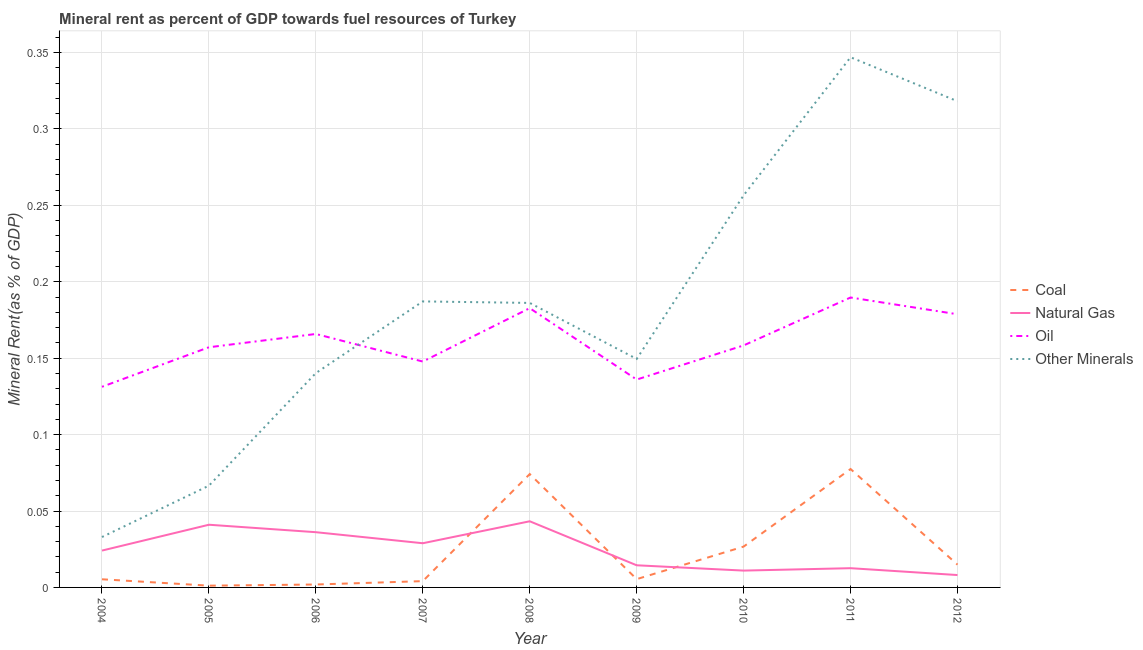How many different coloured lines are there?
Offer a very short reply. 4. Does the line corresponding to coal rent intersect with the line corresponding to oil rent?
Your answer should be very brief. No. Is the number of lines equal to the number of legend labels?
Ensure brevity in your answer.  Yes. What is the  rent of other minerals in 2009?
Provide a succinct answer. 0.15. Across all years, what is the maximum coal rent?
Make the answer very short. 0.08. Across all years, what is the minimum natural gas rent?
Ensure brevity in your answer.  0.01. In which year was the  rent of other minerals minimum?
Your answer should be compact. 2004. What is the total  rent of other minerals in the graph?
Provide a short and direct response. 1.68. What is the difference between the natural gas rent in 2005 and that in 2008?
Provide a short and direct response. -0. What is the difference between the oil rent in 2011 and the coal rent in 2004?
Your answer should be very brief. 0.18. What is the average oil rent per year?
Offer a terse response. 0.16. In the year 2011, what is the difference between the  rent of other minerals and natural gas rent?
Offer a very short reply. 0.33. In how many years, is the natural gas rent greater than 0.12000000000000001 %?
Offer a very short reply. 0. What is the ratio of the  rent of other minerals in 2008 to that in 2010?
Provide a succinct answer. 0.73. Is the oil rent in 2005 less than that in 2009?
Your response must be concise. No. Is the difference between the natural gas rent in 2007 and 2010 greater than the difference between the  rent of other minerals in 2007 and 2010?
Your answer should be very brief. Yes. What is the difference between the highest and the second highest  rent of other minerals?
Provide a short and direct response. 0.03. What is the difference between the highest and the lowest coal rent?
Your answer should be very brief. 0.08. Is the sum of the natural gas rent in 2005 and 2008 greater than the maximum  rent of other minerals across all years?
Provide a short and direct response. No. Is it the case that in every year, the sum of the  rent of other minerals and natural gas rent is greater than the sum of oil rent and coal rent?
Give a very brief answer. No. How many years are there in the graph?
Provide a succinct answer. 9. Does the graph contain any zero values?
Offer a very short reply. No. Does the graph contain grids?
Give a very brief answer. Yes. How are the legend labels stacked?
Ensure brevity in your answer.  Vertical. What is the title of the graph?
Your response must be concise. Mineral rent as percent of GDP towards fuel resources of Turkey. What is the label or title of the X-axis?
Your answer should be very brief. Year. What is the label or title of the Y-axis?
Make the answer very short. Mineral Rent(as % of GDP). What is the Mineral Rent(as % of GDP) in Coal in 2004?
Offer a terse response. 0.01. What is the Mineral Rent(as % of GDP) in Natural Gas in 2004?
Make the answer very short. 0.02. What is the Mineral Rent(as % of GDP) in Oil in 2004?
Offer a very short reply. 0.13. What is the Mineral Rent(as % of GDP) in Other Minerals in 2004?
Give a very brief answer. 0.03. What is the Mineral Rent(as % of GDP) of Coal in 2005?
Give a very brief answer. 0. What is the Mineral Rent(as % of GDP) in Natural Gas in 2005?
Your answer should be very brief. 0.04. What is the Mineral Rent(as % of GDP) in Oil in 2005?
Ensure brevity in your answer.  0.16. What is the Mineral Rent(as % of GDP) in Other Minerals in 2005?
Offer a very short reply. 0.07. What is the Mineral Rent(as % of GDP) in Coal in 2006?
Your answer should be compact. 0. What is the Mineral Rent(as % of GDP) of Natural Gas in 2006?
Make the answer very short. 0.04. What is the Mineral Rent(as % of GDP) in Oil in 2006?
Offer a very short reply. 0.17. What is the Mineral Rent(as % of GDP) in Other Minerals in 2006?
Keep it short and to the point. 0.14. What is the Mineral Rent(as % of GDP) of Coal in 2007?
Your response must be concise. 0. What is the Mineral Rent(as % of GDP) of Natural Gas in 2007?
Provide a succinct answer. 0.03. What is the Mineral Rent(as % of GDP) of Oil in 2007?
Offer a terse response. 0.15. What is the Mineral Rent(as % of GDP) of Other Minerals in 2007?
Ensure brevity in your answer.  0.19. What is the Mineral Rent(as % of GDP) in Coal in 2008?
Provide a succinct answer. 0.07. What is the Mineral Rent(as % of GDP) of Natural Gas in 2008?
Ensure brevity in your answer.  0.04. What is the Mineral Rent(as % of GDP) in Oil in 2008?
Your answer should be compact. 0.18. What is the Mineral Rent(as % of GDP) in Other Minerals in 2008?
Provide a succinct answer. 0.19. What is the Mineral Rent(as % of GDP) of Coal in 2009?
Keep it short and to the point. 0.01. What is the Mineral Rent(as % of GDP) in Natural Gas in 2009?
Keep it short and to the point. 0.01. What is the Mineral Rent(as % of GDP) of Oil in 2009?
Provide a succinct answer. 0.14. What is the Mineral Rent(as % of GDP) in Other Minerals in 2009?
Offer a very short reply. 0.15. What is the Mineral Rent(as % of GDP) in Coal in 2010?
Provide a succinct answer. 0.03. What is the Mineral Rent(as % of GDP) in Natural Gas in 2010?
Offer a very short reply. 0.01. What is the Mineral Rent(as % of GDP) of Oil in 2010?
Make the answer very short. 0.16. What is the Mineral Rent(as % of GDP) in Other Minerals in 2010?
Provide a succinct answer. 0.26. What is the Mineral Rent(as % of GDP) in Coal in 2011?
Offer a terse response. 0.08. What is the Mineral Rent(as % of GDP) of Natural Gas in 2011?
Provide a succinct answer. 0.01. What is the Mineral Rent(as % of GDP) in Oil in 2011?
Give a very brief answer. 0.19. What is the Mineral Rent(as % of GDP) of Other Minerals in 2011?
Your response must be concise. 0.35. What is the Mineral Rent(as % of GDP) in Coal in 2012?
Offer a terse response. 0.01. What is the Mineral Rent(as % of GDP) in Natural Gas in 2012?
Offer a terse response. 0.01. What is the Mineral Rent(as % of GDP) in Oil in 2012?
Give a very brief answer. 0.18. What is the Mineral Rent(as % of GDP) of Other Minerals in 2012?
Your answer should be very brief. 0.32. Across all years, what is the maximum Mineral Rent(as % of GDP) in Coal?
Keep it short and to the point. 0.08. Across all years, what is the maximum Mineral Rent(as % of GDP) in Natural Gas?
Make the answer very short. 0.04. Across all years, what is the maximum Mineral Rent(as % of GDP) in Oil?
Give a very brief answer. 0.19. Across all years, what is the maximum Mineral Rent(as % of GDP) in Other Minerals?
Offer a terse response. 0.35. Across all years, what is the minimum Mineral Rent(as % of GDP) in Coal?
Make the answer very short. 0. Across all years, what is the minimum Mineral Rent(as % of GDP) in Natural Gas?
Keep it short and to the point. 0.01. Across all years, what is the minimum Mineral Rent(as % of GDP) in Oil?
Provide a succinct answer. 0.13. Across all years, what is the minimum Mineral Rent(as % of GDP) in Other Minerals?
Give a very brief answer. 0.03. What is the total Mineral Rent(as % of GDP) in Coal in the graph?
Your answer should be very brief. 0.21. What is the total Mineral Rent(as % of GDP) in Natural Gas in the graph?
Keep it short and to the point. 0.22. What is the total Mineral Rent(as % of GDP) of Oil in the graph?
Your answer should be compact. 1.45. What is the total Mineral Rent(as % of GDP) in Other Minerals in the graph?
Provide a succinct answer. 1.68. What is the difference between the Mineral Rent(as % of GDP) in Coal in 2004 and that in 2005?
Offer a terse response. 0. What is the difference between the Mineral Rent(as % of GDP) in Natural Gas in 2004 and that in 2005?
Provide a short and direct response. -0.02. What is the difference between the Mineral Rent(as % of GDP) in Oil in 2004 and that in 2005?
Offer a terse response. -0.03. What is the difference between the Mineral Rent(as % of GDP) in Other Minerals in 2004 and that in 2005?
Offer a terse response. -0.03. What is the difference between the Mineral Rent(as % of GDP) of Coal in 2004 and that in 2006?
Give a very brief answer. 0. What is the difference between the Mineral Rent(as % of GDP) in Natural Gas in 2004 and that in 2006?
Provide a short and direct response. -0.01. What is the difference between the Mineral Rent(as % of GDP) in Oil in 2004 and that in 2006?
Your answer should be compact. -0.03. What is the difference between the Mineral Rent(as % of GDP) of Other Minerals in 2004 and that in 2006?
Make the answer very short. -0.11. What is the difference between the Mineral Rent(as % of GDP) of Coal in 2004 and that in 2007?
Give a very brief answer. 0. What is the difference between the Mineral Rent(as % of GDP) in Natural Gas in 2004 and that in 2007?
Your answer should be compact. -0. What is the difference between the Mineral Rent(as % of GDP) in Oil in 2004 and that in 2007?
Your response must be concise. -0.02. What is the difference between the Mineral Rent(as % of GDP) in Other Minerals in 2004 and that in 2007?
Keep it short and to the point. -0.15. What is the difference between the Mineral Rent(as % of GDP) of Coal in 2004 and that in 2008?
Offer a very short reply. -0.07. What is the difference between the Mineral Rent(as % of GDP) of Natural Gas in 2004 and that in 2008?
Provide a succinct answer. -0.02. What is the difference between the Mineral Rent(as % of GDP) in Oil in 2004 and that in 2008?
Your answer should be very brief. -0.05. What is the difference between the Mineral Rent(as % of GDP) in Other Minerals in 2004 and that in 2008?
Ensure brevity in your answer.  -0.15. What is the difference between the Mineral Rent(as % of GDP) of Coal in 2004 and that in 2009?
Provide a short and direct response. -0. What is the difference between the Mineral Rent(as % of GDP) in Natural Gas in 2004 and that in 2009?
Your answer should be compact. 0.01. What is the difference between the Mineral Rent(as % of GDP) in Oil in 2004 and that in 2009?
Offer a very short reply. -0. What is the difference between the Mineral Rent(as % of GDP) in Other Minerals in 2004 and that in 2009?
Your response must be concise. -0.12. What is the difference between the Mineral Rent(as % of GDP) of Coal in 2004 and that in 2010?
Your response must be concise. -0.02. What is the difference between the Mineral Rent(as % of GDP) in Natural Gas in 2004 and that in 2010?
Offer a very short reply. 0.01. What is the difference between the Mineral Rent(as % of GDP) in Oil in 2004 and that in 2010?
Your answer should be compact. -0.03. What is the difference between the Mineral Rent(as % of GDP) of Other Minerals in 2004 and that in 2010?
Keep it short and to the point. -0.22. What is the difference between the Mineral Rent(as % of GDP) of Coal in 2004 and that in 2011?
Keep it short and to the point. -0.07. What is the difference between the Mineral Rent(as % of GDP) of Natural Gas in 2004 and that in 2011?
Offer a very short reply. 0.01. What is the difference between the Mineral Rent(as % of GDP) of Oil in 2004 and that in 2011?
Provide a succinct answer. -0.06. What is the difference between the Mineral Rent(as % of GDP) in Other Minerals in 2004 and that in 2011?
Your answer should be very brief. -0.31. What is the difference between the Mineral Rent(as % of GDP) in Coal in 2004 and that in 2012?
Offer a terse response. -0.01. What is the difference between the Mineral Rent(as % of GDP) in Natural Gas in 2004 and that in 2012?
Your answer should be very brief. 0.02. What is the difference between the Mineral Rent(as % of GDP) in Oil in 2004 and that in 2012?
Give a very brief answer. -0.05. What is the difference between the Mineral Rent(as % of GDP) of Other Minerals in 2004 and that in 2012?
Your response must be concise. -0.29. What is the difference between the Mineral Rent(as % of GDP) of Coal in 2005 and that in 2006?
Your response must be concise. -0. What is the difference between the Mineral Rent(as % of GDP) of Natural Gas in 2005 and that in 2006?
Your answer should be compact. 0. What is the difference between the Mineral Rent(as % of GDP) of Oil in 2005 and that in 2006?
Offer a terse response. -0.01. What is the difference between the Mineral Rent(as % of GDP) in Other Minerals in 2005 and that in 2006?
Your answer should be very brief. -0.07. What is the difference between the Mineral Rent(as % of GDP) of Coal in 2005 and that in 2007?
Provide a short and direct response. -0. What is the difference between the Mineral Rent(as % of GDP) in Natural Gas in 2005 and that in 2007?
Provide a succinct answer. 0.01. What is the difference between the Mineral Rent(as % of GDP) of Oil in 2005 and that in 2007?
Keep it short and to the point. 0.01. What is the difference between the Mineral Rent(as % of GDP) in Other Minerals in 2005 and that in 2007?
Your answer should be very brief. -0.12. What is the difference between the Mineral Rent(as % of GDP) in Coal in 2005 and that in 2008?
Offer a very short reply. -0.07. What is the difference between the Mineral Rent(as % of GDP) in Natural Gas in 2005 and that in 2008?
Keep it short and to the point. -0. What is the difference between the Mineral Rent(as % of GDP) in Oil in 2005 and that in 2008?
Your answer should be very brief. -0.03. What is the difference between the Mineral Rent(as % of GDP) in Other Minerals in 2005 and that in 2008?
Your answer should be compact. -0.12. What is the difference between the Mineral Rent(as % of GDP) in Coal in 2005 and that in 2009?
Provide a succinct answer. -0. What is the difference between the Mineral Rent(as % of GDP) in Natural Gas in 2005 and that in 2009?
Provide a short and direct response. 0.03. What is the difference between the Mineral Rent(as % of GDP) in Oil in 2005 and that in 2009?
Your answer should be very brief. 0.02. What is the difference between the Mineral Rent(as % of GDP) in Other Minerals in 2005 and that in 2009?
Give a very brief answer. -0.08. What is the difference between the Mineral Rent(as % of GDP) in Coal in 2005 and that in 2010?
Keep it short and to the point. -0.03. What is the difference between the Mineral Rent(as % of GDP) of Oil in 2005 and that in 2010?
Keep it short and to the point. -0. What is the difference between the Mineral Rent(as % of GDP) of Other Minerals in 2005 and that in 2010?
Offer a very short reply. -0.19. What is the difference between the Mineral Rent(as % of GDP) of Coal in 2005 and that in 2011?
Provide a short and direct response. -0.08. What is the difference between the Mineral Rent(as % of GDP) in Natural Gas in 2005 and that in 2011?
Your answer should be very brief. 0.03. What is the difference between the Mineral Rent(as % of GDP) in Oil in 2005 and that in 2011?
Your answer should be compact. -0.03. What is the difference between the Mineral Rent(as % of GDP) in Other Minerals in 2005 and that in 2011?
Ensure brevity in your answer.  -0.28. What is the difference between the Mineral Rent(as % of GDP) of Coal in 2005 and that in 2012?
Your answer should be very brief. -0.01. What is the difference between the Mineral Rent(as % of GDP) in Natural Gas in 2005 and that in 2012?
Make the answer very short. 0.03. What is the difference between the Mineral Rent(as % of GDP) in Oil in 2005 and that in 2012?
Make the answer very short. -0.02. What is the difference between the Mineral Rent(as % of GDP) in Other Minerals in 2005 and that in 2012?
Your response must be concise. -0.25. What is the difference between the Mineral Rent(as % of GDP) of Coal in 2006 and that in 2007?
Provide a succinct answer. -0. What is the difference between the Mineral Rent(as % of GDP) of Natural Gas in 2006 and that in 2007?
Provide a succinct answer. 0.01. What is the difference between the Mineral Rent(as % of GDP) of Oil in 2006 and that in 2007?
Make the answer very short. 0.02. What is the difference between the Mineral Rent(as % of GDP) of Other Minerals in 2006 and that in 2007?
Your answer should be compact. -0.05. What is the difference between the Mineral Rent(as % of GDP) in Coal in 2006 and that in 2008?
Provide a short and direct response. -0.07. What is the difference between the Mineral Rent(as % of GDP) in Natural Gas in 2006 and that in 2008?
Your answer should be compact. -0.01. What is the difference between the Mineral Rent(as % of GDP) in Oil in 2006 and that in 2008?
Give a very brief answer. -0.02. What is the difference between the Mineral Rent(as % of GDP) of Other Minerals in 2006 and that in 2008?
Ensure brevity in your answer.  -0.05. What is the difference between the Mineral Rent(as % of GDP) of Coal in 2006 and that in 2009?
Your answer should be compact. -0. What is the difference between the Mineral Rent(as % of GDP) of Natural Gas in 2006 and that in 2009?
Offer a terse response. 0.02. What is the difference between the Mineral Rent(as % of GDP) in Oil in 2006 and that in 2009?
Offer a terse response. 0.03. What is the difference between the Mineral Rent(as % of GDP) in Other Minerals in 2006 and that in 2009?
Give a very brief answer. -0.01. What is the difference between the Mineral Rent(as % of GDP) of Coal in 2006 and that in 2010?
Make the answer very short. -0.02. What is the difference between the Mineral Rent(as % of GDP) in Natural Gas in 2006 and that in 2010?
Make the answer very short. 0.03. What is the difference between the Mineral Rent(as % of GDP) of Oil in 2006 and that in 2010?
Your answer should be very brief. 0.01. What is the difference between the Mineral Rent(as % of GDP) in Other Minerals in 2006 and that in 2010?
Your answer should be very brief. -0.12. What is the difference between the Mineral Rent(as % of GDP) in Coal in 2006 and that in 2011?
Keep it short and to the point. -0.08. What is the difference between the Mineral Rent(as % of GDP) of Natural Gas in 2006 and that in 2011?
Your answer should be compact. 0.02. What is the difference between the Mineral Rent(as % of GDP) in Oil in 2006 and that in 2011?
Keep it short and to the point. -0.02. What is the difference between the Mineral Rent(as % of GDP) of Other Minerals in 2006 and that in 2011?
Your answer should be compact. -0.21. What is the difference between the Mineral Rent(as % of GDP) in Coal in 2006 and that in 2012?
Offer a terse response. -0.01. What is the difference between the Mineral Rent(as % of GDP) of Natural Gas in 2006 and that in 2012?
Provide a succinct answer. 0.03. What is the difference between the Mineral Rent(as % of GDP) in Oil in 2006 and that in 2012?
Your answer should be very brief. -0.01. What is the difference between the Mineral Rent(as % of GDP) in Other Minerals in 2006 and that in 2012?
Provide a succinct answer. -0.18. What is the difference between the Mineral Rent(as % of GDP) in Coal in 2007 and that in 2008?
Your answer should be very brief. -0.07. What is the difference between the Mineral Rent(as % of GDP) of Natural Gas in 2007 and that in 2008?
Provide a succinct answer. -0.01. What is the difference between the Mineral Rent(as % of GDP) of Oil in 2007 and that in 2008?
Your response must be concise. -0.03. What is the difference between the Mineral Rent(as % of GDP) of Other Minerals in 2007 and that in 2008?
Your answer should be compact. 0. What is the difference between the Mineral Rent(as % of GDP) of Coal in 2007 and that in 2009?
Provide a short and direct response. -0. What is the difference between the Mineral Rent(as % of GDP) in Natural Gas in 2007 and that in 2009?
Offer a very short reply. 0.01. What is the difference between the Mineral Rent(as % of GDP) of Oil in 2007 and that in 2009?
Ensure brevity in your answer.  0.01. What is the difference between the Mineral Rent(as % of GDP) of Other Minerals in 2007 and that in 2009?
Your answer should be very brief. 0.04. What is the difference between the Mineral Rent(as % of GDP) in Coal in 2007 and that in 2010?
Make the answer very short. -0.02. What is the difference between the Mineral Rent(as % of GDP) of Natural Gas in 2007 and that in 2010?
Ensure brevity in your answer.  0.02. What is the difference between the Mineral Rent(as % of GDP) of Oil in 2007 and that in 2010?
Your answer should be compact. -0.01. What is the difference between the Mineral Rent(as % of GDP) of Other Minerals in 2007 and that in 2010?
Keep it short and to the point. -0.07. What is the difference between the Mineral Rent(as % of GDP) in Coal in 2007 and that in 2011?
Ensure brevity in your answer.  -0.07. What is the difference between the Mineral Rent(as % of GDP) in Natural Gas in 2007 and that in 2011?
Keep it short and to the point. 0.02. What is the difference between the Mineral Rent(as % of GDP) of Oil in 2007 and that in 2011?
Your response must be concise. -0.04. What is the difference between the Mineral Rent(as % of GDP) of Other Minerals in 2007 and that in 2011?
Provide a succinct answer. -0.16. What is the difference between the Mineral Rent(as % of GDP) in Coal in 2007 and that in 2012?
Provide a short and direct response. -0.01. What is the difference between the Mineral Rent(as % of GDP) of Natural Gas in 2007 and that in 2012?
Your answer should be compact. 0.02. What is the difference between the Mineral Rent(as % of GDP) of Oil in 2007 and that in 2012?
Provide a succinct answer. -0.03. What is the difference between the Mineral Rent(as % of GDP) in Other Minerals in 2007 and that in 2012?
Offer a very short reply. -0.13. What is the difference between the Mineral Rent(as % of GDP) in Coal in 2008 and that in 2009?
Your answer should be very brief. 0.07. What is the difference between the Mineral Rent(as % of GDP) of Natural Gas in 2008 and that in 2009?
Give a very brief answer. 0.03. What is the difference between the Mineral Rent(as % of GDP) in Oil in 2008 and that in 2009?
Make the answer very short. 0.05. What is the difference between the Mineral Rent(as % of GDP) of Other Minerals in 2008 and that in 2009?
Provide a short and direct response. 0.04. What is the difference between the Mineral Rent(as % of GDP) in Coal in 2008 and that in 2010?
Provide a succinct answer. 0.05. What is the difference between the Mineral Rent(as % of GDP) of Natural Gas in 2008 and that in 2010?
Your answer should be compact. 0.03. What is the difference between the Mineral Rent(as % of GDP) of Oil in 2008 and that in 2010?
Your answer should be very brief. 0.02. What is the difference between the Mineral Rent(as % of GDP) of Other Minerals in 2008 and that in 2010?
Your response must be concise. -0.07. What is the difference between the Mineral Rent(as % of GDP) of Coal in 2008 and that in 2011?
Provide a succinct answer. -0. What is the difference between the Mineral Rent(as % of GDP) of Natural Gas in 2008 and that in 2011?
Make the answer very short. 0.03. What is the difference between the Mineral Rent(as % of GDP) of Oil in 2008 and that in 2011?
Provide a succinct answer. -0.01. What is the difference between the Mineral Rent(as % of GDP) of Other Minerals in 2008 and that in 2011?
Your response must be concise. -0.16. What is the difference between the Mineral Rent(as % of GDP) in Coal in 2008 and that in 2012?
Provide a succinct answer. 0.06. What is the difference between the Mineral Rent(as % of GDP) of Natural Gas in 2008 and that in 2012?
Make the answer very short. 0.04. What is the difference between the Mineral Rent(as % of GDP) of Oil in 2008 and that in 2012?
Keep it short and to the point. 0. What is the difference between the Mineral Rent(as % of GDP) of Other Minerals in 2008 and that in 2012?
Provide a short and direct response. -0.13. What is the difference between the Mineral Rent(as % of GDP) in Coal in 2009 and that in 2010?
Your answer should be very brief. -0.02. What is the difference between the Mineral Rent(as % of GDP) in Natural Gas in 2009 and that in 2010?
Keep it short and to the point. 0. What is the difference between the Mineral Rent(as % of GDP) in Oil in 2009 and that in 2010?
Your response must be concise. -0.02. What is the difference between the Mineral Rent(as % of GDP) in Other Minerals in 2009 and that in 2010?
Your answer should be very brief. -0.11. What is the difference between the Mineral Rent(as % of GDP) in Coal in 2009 and that in 2011?
Make the answer very short. -0.07. What is the difference between the Mineral Rent(as % of GDP) of Natural Gas in 2009 and that in 2011?
Keep it short and to the point. 0. What is the difference between the Mineral Rent(as % of GDP) in Oil in 2009 and that in 2011?
Provide a short and direct response. -0.05. What is the difference between the Mineral Rent(as % of GDP) of Other Minerals in 2009 and that in 2011?
Give a very brief answer. -0.2. What is the difference between the Mineral Rent(as % of GDP) of Coal in 2009 and that in 2012?
Offer a very short reply. -0.01. What is the difference between the Mineral Rent(as % of GDP) of Natural Gas in 2009 and that in 2012?
Provide a succinct answer. 0.01. What is the difference between the Mineral Rent(as % of GDP) of Oil in 2009 and that in 2012?
Offer a terse response. -0.04. What is the difference between the Mineral Rent(as % of GDP) of Other Minerals in 2009 and that in 2012?
Your answer should be compact. -0.17. What is the difference between the Mineral Rent(as % of GDP) of Coal in 2010 and that in 2011?
Your answer should be very brief. -0.05. What is the difference between the Mineral Rent(as % of GDP) in Natural Gas in 2010 and that in 2011?
Your answer should be very brief. -0. What is the difference between the Mineral Rent(as % of GDP) of Oil in 2010 and that in 2011?
Your answer should be compact. -0.03. What is the difference between the Mineral Rent(as % of GDP) in Other Minerals in 2010 and that in 2011?
Offer a terse response. -0.09. What is the difference between the Mineral Rent(as % of GDP) of Coal in 2010 and that in 2012?
Make the answer very short. 0.01. What is the difference between the Mineral Rent(as % of GDP) in Natural Gas in 2010 and that in 2012?
Provide a short and direct response. 0. What is the difference between the Mineral Rent(as % of GDP) in Oil in 2010 and that in 2012?
Your response must be concise. -0.02. What is the difference between the Mineral Rent(as % of GDP) in Other Minerals in 2010 and that in 2012?
Offer a terse response. -0.06. What is the difference between the Mineral Rent(as % of GDP) of Coal in 2011 and that in 2012?
Offer a very short reply. 0.06. What is the difference between the Mineral Rent(as % of GDP) of Natural Gas in 2011 and that in 2012?
Your response must be concise. 0. What is the difference between the Mineral Rent(as % of GDP) in Oil in 2011 and that in 2012?
Ensure brevity in your answer.  0.01. What is the difference between the Mineral Rent(as % of GDP) of Other Minerals in 2011 and that in 2012?
Give a very brief answer. 0.03. What is the difference between the Mineral Rent(as % of GDP) in Coal in 2004 and the Mineral Rent(as % of GDP) in Natural Gas in 2005?
Keep it short and to the point. -0.04. What is the difference between the Mineral Rent(as % of GDP) of Coal in 2004 and the Mineral Rent(as % of GDP) of Oil in 2005?
Give a very brief answer. -0.15. What is the difference between the Mineral Rent(as % of GDP) of Coal in 2004 and the Mineral Rent(as % of GDP) of Other Minerals in 2005?
Provide a succinct answer. -0.06. What is the difference between the Mineral Rent(as % of GDP) in Natural Gas in 2004 and the Mineral Rent(as % of GDP) in Oil in 2005?
Keep it short and to the point. -0.13. What is the difference between the Mineral Rent(as % of GDP) in Natural Gas in 2004 and the Mineral Rent(as % of GDP) in Other Minerals in 2005?
Your answer should be very brief. -0.04. What is the difference between the Mineral Rent(as % of GDP) in Oil in 2004 and the Mineral Rent(as % of GDP) in Other Minerals in 2005?
Your response must be concise. 0.06. What is the difference between the Mineral Rent(as % of GDP) of Coal in 2004 and the Mineral Rent(as % of GDP) of Natural Gas in 2006?
Provide a short and direct response. -0.03. What is the difference between the Mineral Rent(as % of GDP) in Coal in 2004 and the Mineral Rent(as % of GDP) in Oil in 2006?
Your answer should be compact. -0.16. What is the difference between the Mineral Rent(as % of GDP) in Coal in 2004 and the Mineral Rent(as % of GDP) in Other Minerals in 2006?
Offer a terse response. -0.13. What is the difference between the Mineral Rent(as % of GDP) in Natural Gas in 2004 and the Mineral Rent(as % of GDP) in Oil in 2006?
Give a very brief answer. -0.14. What is the difference between the Mineral Rent(as % of GDP) of Natural Gas in 2004 and the Mineral Rent(as % of GDP) of Other Minerals in 2006?
Offer a very short reply. -0.12. What is the difference between the Mineral Rent(as % of GDP) in Oil in 2004 and the Mineral Rent(as % of GDP) in Other Minerals in 2006?
Offer a very short reply. -0.01. What is the difference between the Mineral Rent(as % of GDP) of Coal in 2004 and the Mineral Rent(as % of GDP) of Natural Gas in 2007?
Your answer should be very brief. -0.02. What is the difference between the Mineral Rent(as % of GDP) in Coal in 2004 and the Mineral Rent(as % of GDP) in Oil in 2007?
Your response must be concise. -0.14. What is the difference between the Mineral Rent(as % of GDP) of Coal in 2004 and the Mineral Rent(as % of GDP) of Other Minerals in 2007?
Make the answer very short. -0.18. What is the difference between the Mineral Rent(as % of GDP) in Natural Gas in 2004 and the Mineral Rent(as % of GDP) in Oil in 2007?
Your response must be concise. -0.12. What is the difference between the Mineral Rent(as % of GDP) in Natural Gas in 2004 and the Mineral Rent(as % of GDP) in Other Minerals in 2007?
Provide a short and direct response. -0.16. What is the difference between the Mineral Rent(as % of GDP) of Oil in 2004 and the Mineral Rent(as % of GDP) of Other Minerals in 2007?
Your response must be concise. -0.06. What is the difference between the Mineral Rent(as % of GDP) in Coal in 2004 and the Mineral Rent(as % of GDP) in Natural Gas in 2008?
Provide a short and direct response. -0.04. What is the difference between the Mineral Rent(as % of GDP) in Coal in 2004 and the Mineral Rent(as % of GDP) in Oil in 2008?
Your answer should be compact. -0.18. What is the difference between the Mineral Rent(as % of GDP) in Coal in 2004 and the Mineral Rent(as % of GDP) in Other Minerals in 2008?
Your answer should be compact. -0.18. What is the difference between the Mineral Rent(as % of GDP) of Natural Gas in 2004 and the Mineral Rent(as % of GDP) of Oil in 2008?
Offer a very short reply. -0.16. What is the difference between the Mineral Rent(as % of GDP) of Natural Gas in 2004 and the Mineral Rent(as % of GDP) of Other Minerals in 2008?
Make the answer very short. -0.16. What is the difference between the Mineral Rent(as % of GDP) in Oil in 2004 and the Mineral Rent(as % of GDP) in Other Minerals in 2008?
Ensure brevity in your answer.  -0.05. What is the difference between the Mineral Rent(as % of GDP) of Coal in 2004 and the Mineral Rent(as % of GDP) of Natural Gas in 2009?
Provide a succinct answer. -0.01. What is the difference between the Mineral Rent(as % of GDP) of Coal in 2004 and the Mineral Rent(as % of GDP) of Oil in 2009?
Your answer should be very brief. -0.13. What is the difference between the Mineral Rent(as % of GDP) in Coal in 2004 and the Mineral Rent(as % of GDP) in Other Minerals in 2009?
Offer a very short reply. -0.14. What is the difference between the Mineral Rent(as % of GDP) in Natural Gas in 2004 and the Mineral Rent(as % of GDP) in Oil in 2009?
Provide a short and direct response. -0.11. What is the difference between the Mineral Rent(as % of GDP) of Natural Gas in 2004 and the Mineral Rent(as % of GDP) of Other Minerals in 2009?
Your answer should be very brief. -0.13. What is the difference between the Mineral Rent(as % of GDP) of Oil in 2004 and the Mineral Rent(as % of GDP) of Other Minerals in 2009?
Offer a terse response. -0.02. What is the difference between the Mineral Rent(as % of GDP) in Coal in 2004 and the Mineral Rent(as % of GDP) in Natural Gas in 2010?
Your response must be concise. -0.01. What is the difference between the Mineral Rent(as % of GDP) in Coal in 2004 and the Mineral Rent(as % of GDP) in Oil in 2010?
Your answer should be compact. -0.15. What is the difference between the Mineral Rent(as % of GDP) of Coal in 2004 and the Mineral Rent(as % of GDP) of Other Minerals in 2010?
Keep it short and to the point. -0.25. What is the difference between the Mineral Rent(as % of GDP) of Natural Gas in 2004 and the Mineral Rent(as % of GDP) of Oil in 2010?
Offer a terse response. -0.13. What is the difference between the Mineral Rent(as % of GDP) of Natural Gas in 2004 and the Mineral Rent(as % of GDP) of Other Minerals in 2010?
Provide a succinct answer. -0.23. What is the difference between the Mineral Rent(as % of GDP) in Oil in 2004 and the Mineral Rent(as % of GDP) in Other Minerals in 2010?
Give a very brief answer. -0.13. What is the difference between the Mineral Rent(as % of GDP) in Coal in 2004 and the Mineral Rent(as % of GDP) in Natural Gas in 2011?
Make the answer very short. -0.01. What is the difference between the Mineral Rent(as % of GDP) of Coal in 2004 and the Mineral Rent(as % of GDP) of Oil in 2011?
Keep it short and to the point. -0.18. What is the difference between the Mineral Rent(as % of GDP) of Coal in 2004 and the Mineral Rent(as % of GDP) of Other Minerals in 2011?
Provide a succinct answer. -0.34. What is the difference between the Mineral Rent(as % of GDP) in Natural Gas in 2004 and the Mineral Rent(as % of GDP) in Oil in 2011?
Your answer should be compact. -0.17. What is the difference between the Mineral Rent(as % of GDP) of Natural Gas in 2004 and the Mineral Rent(as % of GDP) of Other Minerals in 2011?
Your answer should be compact. -0.32. What is the difference between the Mineral Rent(as % of GDP) in Oil in 2004 and the Mineral Rent(as % of GDP) in Other Minerals in 2011?
Provide a short and direct response. -0.22. What is the difference between the Mineral Rent(as % of GDP) in Coal in 2004 and the Mineral Rent(as % of GDP) in Natural Gas in 2012?
Offer a terse response. -0. What is the difference between the Mineral Rent(as % of GDP) of Coal in 2004 and the Mineral Rent(as % of GDP) of Oil in 2012?
Your answer should be very brief. -0.17. What is the difference between the Mineral Rent(as % of GDP) in Coal in 2004 and the Mineral Rent(as % of GDP) in Other Minerals in 2012?
Your response must be concise. -0.31. What is the difference between the Mineral Rent(as % of GDP) in Natural Gas in 2004 and the Mineral Rent(as % of GDP) in Oil in 2012?
Your answer should be compact. -0.15. What is the difference between the Mineral Rent(as % of GDP) of Natural Gas in 2004 and the Mineral Rent(as % of GDP) of Other Minerals in 2012?
Keep it short and to the point. -0.29. What is the difference between the Mineral Rent(as % of GDP) of Oil in 2004 and the Mineral Rent(as % of GDP) of Other Minerals in 2012?
Offer a terse response. -0.19. What is the difference between the Mineral Rent(as % of GDP) of Coal in 2005 and the Mineral Rent(as % of GDP) of Natural Gas in 2006?
Your response must be concise. -0.04. What is the difference between the Mineral Rent(as % of GDP) of Coal in 2005 and the Mineral Rent(as % of GDP) of Oil in 2006?
Provide a short and direct response. -0.16. What is the difference between the Mineral Rent(as % of GDP) in Coal in 2005 and the Mineral Rent(as % of GDP) in Other Minerals in 2006?
Ensure brevity in your answer.  -0.14. What is the difference between the Mineral Rent(as % of GDP) of Natural Gas in 2005 and the Mineral Rent(as % of GDP) of Oil in 2006?
Ensure brevity in your answer.  -0.12. What is the difference between the Mineral Rent(as % of GDP) of Natural Gas in 2005 and the Mineral Rent(as % of GDP) of Other Minerals in 2006?
Ensure brevity in your answer.  -0.1. What is the difference between the Mineral Rent(as % of GDP) in Oil in 2005 and the Mineral Rent(as % of GDP) in Other Minerals in 2006?
Your response must be concise. 0.02. What is the difference between the Mineral Rent(as % of GDP) in Coal in 2005 and the Mineral Rent(as % of GDP) in Natural Gas in 2007?
Provide a short and direct response. -0.03. What is the difference between the Mineral Rent(as % of GDP) of Coal in 2005 and the Mineral Rent(as % of GDP) of Oil in 2007?
Offer a terse response. -0.15. What is the difference between the Mineral Rent(as % of GDP) in Coal in 2005 and the Mineral Rent(as % of GDP) in Other Minerals in 2007?
Your response must be concise. -0.19. What is the difference between the Mineral Rent(as % of GDP) of Natural Gas in 2005 and the Mineral Rent(as % of GDP) of Oil in 2007?
Ensure brevity in your answer.  -0.11. What is the difference between the Mineral Rent(as % of GDP) of Natural Gas in 2005 and the Mineral Rent(as % of GDP) of Other Minerals in 2007?
Make the answer very short. -0.15. What is the difference between the Mineral Rent(as % of GDP) in Oil in 2005 and the Mineral Rent(as % of GDP) in Other Minerals in 2007?
Keep it short and to the point. -0.03. What is the difference between the Mineral Rent(as % of GDP) of Coal in 2005 and the Mineral Rent(as % of GDP) of Natural Gas in 2008?
Provide a short and direct response. -0.04. What is the difference between the Mineral Rent(as % of GDP) of Coal in 2005 and the Mineral Rent(as % of GDP) of Oil in 2008?
Your response must be concise. -0.18. What is the difference between the Mineral Rent(as % of GDP) in Coal in 2005 and the Mineral Rent(as % of GDP) in Other Minerals in 2008?
Offer a terse response. -0.18. What is the difference between the Mineral Rent(as % of GDP) of Natural Gas in 2005 and the Mineral Rent(as % of GDP) of Oil in 2008?
Provide a short and direct response. -0.14. What is the difference between the Mineral Rent(as % of GDP) of Natural Gas in 2005 and the Mineral Rent(as % of GDP) of Other Minerals in 2008?
Offer a very short reply. -0.15. What is the difference between the Mineral Rent(as % of GDP) in Oil in 2005 and the Mineral Rent(as % of GDP) in Other Minerals in 2008?
Your answer should be very brief. -0.03. What is the difference between the Mineral Rent(as % of GDP) of Coal in 2005 and the Mineral Rent(as % of GDP) of Natural Gas in 2009?
Provide a succinct answer. -0.01. What is the difference between the Mineral Rent(as % of GDP) in Coal in 2005 and the Mineral Rent(as % of GDP) in Oil in 2009?
Your answer should be very brief. -0.13. What is the difference between the Mineral Rent(as % of GDP) of Coal in 2005 and the Mineral Rent(as % of GDP) of Other Minerals in 2009?
Your answer should be very brief. -0.15. What is the difference between the Mineral Rent(as % of GDP) in Natural Gas in 2005 and the Mineral Rent(as % of GDP) in Oil in 2009?
Your answer should be compact. -0.1. What is the difference between the Mineral Rent(as % of GDP) in Natural Gas in 2005 and the Mineral Rent(as % of GDP) in Other Minerals in 2009?
Provide a short and direct response. -0.11. What is the difference between the Mineral Rent(as % of GDP) of Oil in 2005 and the Mineral Rent(as % of GDP) of Other Minerals in 2009?
Provide a succinct answer. 0.01. What is the difference between the Mineral Rent(as % of GDP) of Coal in 2005 and the Mineral Rent(as % of GDP) of Natural Gas in 2010?
Ensure brevity in your answer.  -0.01. What is the difference between the Mineral Rent(as % of GDP) in Coal in 2005 and the Mineral Rent(as % of GDP) in Oil in 2010?
Offer a very short reply. -0.16. What is the difference between the Mineral Rent(as % of GDP) of Coal in 2005 and the Mineral Rent(as % of GDP) of Other Minerals in 2010?
Offer a terse response. -0.26. What is the difference between the Mineral Rent(as % of GDP) in Natural Gas in 2005 and the Mineral Rent(as % of GDP) in Oil in 2010?
Your answer should be very brief. -0.12. What is the difference between the Mineral Rent(as % of GDP) of Natural Gas in 2005 and the Mineral Rent(as % of GDP) of Other Minerals in 2010?
Offer a very short reply. -0.22. What is the difference between the Mineral Rent(as % of GDP) in Oil in 2005 and the Mineral Rent(as % of GDP) in Other Minerals in 2010?
Provide a short and direct response. -0.1. What is the difference between the Mineral Rent(as % of GDP) in Coal in 2005 and the Mineral Rent(as % of GDP) in Natural Gas in 2011?
Offer a terse response. -0.01. What is the difference between the Mineral Rent(as % of GDP) in Coal in 2005 and the Mineral Rent(as % of GDP) in Oil in 2011?
Keep it short and to the point. -0.19. What is the difference between the Mineral Rent(as % of GDP) of Coal in 2005 and the Mineral Rent(as % of GDP) of Other Minerals in 2011?
Your answer should be compact. -0.35. What is the difference between the Mineral Rent(as % of GDP) in Natural Gas in 2005 and the Mineral Rent(as % of GDP) in Oil in 2011?
Provide a succinct answer. -0.15. What is the difference between the Mineral Rent(as % of GDP) of Natural Gas in 2005 and the Mineral Rent(as % of GDP) of Other Minerals in 2011?
Your response must be concise. -0.31. What is the difference between the Mineral Rent(as % of GDP) of Oil in 2005 and the Mineral Rent(as % of GDP) of Other Minerals in 2011?
Provide a succinct answer. -0.19. What is the difference between the Mineral Rent(as % of GDP) of Coal in 2005 and the Mineral Rent(as % of GDP) of Natural Gas in 2012?
Ensure brevity in your answer.  -0.01. What is the difference between the Mineral Rent(as % of GDP) in Coal in 2005 and the Mineral Rent(as % of GDP) in Oil in 2012?
Your response must be concise. -0.18. What is the difference between the Mineral Rent(as % of GDP) of Coal in 2005 and the Mineral Rent(as % of GDP) of Other Minerals in 2012?
Keep it short and to the point. -0.32. What is the difference between the Mineral Rent(as % of GDP) of Natural Gas in 2005 and the Mineral Rent(as % of GDP) of Oil in 2012?
Offer a very short reply. -0.14. What is the difference between the Mineral Rent(as % of GDP) in Natural Gas in 2005 and the Mineral Rent(as % of GDP) in Other Minerals in 2012?
Keep it short and to the point. -0.28. What is the difference between the Mineral Rent(as % of GDP) of Oil in 2005 and the Mineral Rent(as % of GDP) of Other Minerals in 2012?
Your answer should be compact. -0.16. What is the difference between the Mineral Rent(as % of GDP) in Coal in 2006 and the Mineral Rent(as % of GDP) in Natural Gas in 2007?
Keep it short and to the point. -0.03. What is the difference between the Mineral Rent(as % of GDP) in Coal in 2006 and the Mineral Rent(as % of GDP) in Oil in 2007?
Your answer should be compact. -0.15. What is the difference between the Mineral Rent(as % of GDP) in Coal in 2006 and the Mineral Rent(as % of GDP) in Other Minerals in 2007?
Your answer should be compact. -0.19. What is the difference between the Mineral Rent(as % of GDP) in Natural Gas in 2006 and the Mineral Rent(as % of GDP) in Oil in 2007?
Your answer should be compact. -0.11. What is the difference between the Mineral Rent(as % of GDP) of Natural Gas in 2006 and the Mineral Rent(as % of GDP) of Other Minerals in 2007?
Your response must be concise. -0.15. What is the difference between the Mineral Rent(as % of GDP) in Oil in 2006 and the Mineral Rent(as % of GDP) in Other Minerals in 2007?
Your response must be concise. -0.02. What is the difference between the Mineral Rent(as % of GDP) of Coal in 2006 and the Mineral Rent(as % of GDP) of Natural Gas in 2008?
Your answer should be very brief. -0.04. What is the difference between the Mineral Rent(as % of GDP) in Coal in 2006 and the Mineral Rent(as % of GDP) in Oil in 2008?
Give a very brief answer. -0.18. What is the difference between the Mineral Rent(as % of GDP) in Coal in 2006 and the Mineral Rent(as % of GDP) in Other Minerals in 2008?
Ensure brevity in your answer.  -0.18. What is the difference between the Mineral Rent(as % of GDP) of Natural Gas in 2006 and the Mineral Rent(as % of GDP) of Oil in 2008?
Offer a terse response. -0.15. What is the difference between the Mineral Rent(as % of GDP) of Natural Gas in 2006 and the Mineral Rent(as % of GDP) of Other Minerals in 2008?
Offer a very short reply. -0.15. What is the difference between the Mineral Rent(as % of GDP) in Oil in 2006 and the Mineral Rent(as % of GDP) in Other Minerals in 2008?
Provide a short and direct response. -0.02. What is the difference between the Mineral Rent(as % of GDP) in Coal in 2006 and the Mineral Rent(as % of GDP) in Natural Gas in 2009?
Keep it short and to the point. -0.01. What is the difference between the Mineral Rent(as % of GDP) of Coal in 2006 and the Mineral Rent(as % of GDP) of Oil in 2009?
Offer a terse response. -0.13. What is the difference between the Mineral Rent(as % of GDP) in Coal in 2006 and the Mineral Rent(as % of GDP) in Other Minerals in 2009?
Offer a very short reply. -0.15. What is the difference between the Mineral Rent(as % of GDP) in Natural Gas in 2006 and the Mineral Rent(as % of GDP) in Oil in 2009?
Provide a short and direct response. -0.1. What is the difference between the Mineral Rent(as % of GDP) in Natural Gas in 2006 and the Mineral Rent(as % of GDP) in Other Minerals in 2009?
Give a very brief answer. -0.11. What is the difference between the Mineral Rent(as % of GDP) of Oil in 2006 and the Mineral Rent(as % of GDP) of Other Minerals in 2009?
Keep it short and to the point. 0.02. What is the difference between the Mineral Rent(as % of GDP) of Coal in 2006 and the Mineral Rent(as % of GDP) of Natural Gas in 2010?
Your answer should be compact. -0.01. What is the difference between the Mineral Rent(as % of GDP) of Coal in 2006 and the Mineral Rent(as % of GDP) of Oil in 2010?
Provide a succinct answer. -0.16. What is the difference between the Mineral Rent(as % of GDP) of Coal in 2006 and the Mineral Rent(as % of GDP) of Other Minerals in 2010?
Your answer should be very brief. -0.25. What is the difference between the Mineral Rent(as % of GDP) in Natural Gas in 2006 and the Mineral Rent(as % of GDP) in Oil in 2010?
Keep it short and to the point. -0.12. What is the difference between the Mineral Rent(as % of GDP) of Natural Gas in 2006 and the Mineral Rent(as % of GDP) of Other Minerals in 2010?
Ensure brevity in your answer.  -0.22. What is the difference between the Mineral Rent(as % of GDP) of Oil in 2006 and the Mineral Rent(as % of GDP) of Other Minerals in 2010?
Make the answer very short. -0.09. What is the difference between the Mineral Rent(as % of GDP) of Coal in 2006 and the Mineral Rent(as % of GDP) of Natural Gas in 2011?
Provide a succinct answer. -0.01. What is the difference between the Mineral Rent(as % of GDP) in Coal in 2006 and the Mineral Rent(as % of GDP) in Oil in 2011?
Offer a very short reply. -0.19. What is the difference between the Mineral Rent(as % of GDP) of Coal in 2006 and the Mineral Rent(as % of GDP) of Other Minerals in 2011?
Your answer should be very brief. -0.34. What is the difference between the Mineral Rent(as % of GDP) of Natural Gas in 2006 and the Mineral Rent(as % of GDP) of Oil in 2011?
Give a very brief answer. -0.15. What is the difference between the Mineral Rent(as % of GDP) of Natural Gas in 2006 and the Mineral Rent(as % of GDP) of Other Minerals in 2011?
Offer a terse response. -0.31. What is the difference between the Mineral Rent(as % of GDP) in Oil in 2006 and the Mineral Rent(as % of GDP) in Other Minerals in 2011?
Offer a very short reply. -0.18. What is the difference between the Mineral Rent(as % of GDP) in Coal in 2006 and the Mineral Rent(as % of GDP) in Natural Gas in 2012?
Make the answer very short. -0.01. What is the difference between the Mineral Rent(as % of GDP) in Coal in 2006 and the Mineral Rent(as % of GDP) in Oil in 2012?
Your response must be concise. -0.18. What is the difference between the Mineral Rent(as % of GDP) in Coal in 2006 and the Mineral Rent(as % of GDP) in Other Minerals in 2012?
Keep it short and to the point. -0.32. What is the difference between the Mineral Rent(as % of GDP) of Natural Gas in 2006 and the Mineral Rent(as % of GDP) of Oil in 2012?
Give a very brief answer. -0.14. What is the difference between the Mineral Rent(as % of GDP) of Natural Gas in 2006 and the Mineral Rent(as % of GDP) of Other Minerals in 2012?
Your answer should be compact. -0.28. What is the difference between the Mineral Rent(as % of GDP) in Oil in 2006 and the Mineral Rent(as % of GDP) in Other Minerals in 2012?
Offer a terse response. -0.15. What is the difference between the Mineral Rent(as % of GDP) in Coal in 2007 and the Mineral Rent(as % of GDP) in Natural Gas in 2008?
Keep it short and to the point. -0.04. What is the difference between the Mineral Rent(as % of GDP) in Coal in 2007 and the Mineral Rent(as % of GDP) in Oil in 2008?
Offer a terse response. -0.18. What is the difference between the Mineral Rent(as % of GDP) in Coal in 2007 and the Mineral Rent(as % of GDP) in Other Minerals in 2008?
Your answer should be very brief. -0.18. What is the difference between the Mineral Rent(as % of GDP) of Natural Gas in 2007 and the Mineral Rent(as % of GDP) of Oil in 2008?
Keep it short and to the point. -0.15. What is the difference between the Mineral Rent(as % of GDP) of Natural Gas in 2007 and the Mineral Rent(as % of GDP) of Other Minerals in 2008?
Your answer should be compact. -0.16. What is the difference between the Mineral Rent(as % of GDP) in Oil in 2007 and the Mineral Rent(as % of GDP) in Other Minerals in 2008?
Offer a terse response. -0.04. What is the difference between the Mineral Rent(as % of GDP) of Coal in 2007 and the Mineral Rent(as % of GDP) of Natural Gas in 2009?
Provide a succinct answer. -0.01. What is the difference between the Mineral Rent(as % of GDP) in Coal in 2007 and the Mineral Rent(as % of GDP) in Oil in 2009?
Your answer should be compact. -0.13. What is the difference between the Mineral Rent(as % of GDP) of Coal in 2007 and the Mineral Rent(as % of GDP) of Other Minerals in 2009?
Make the answer very short. -0.15. What is the difference between the Mineral Rent(as % of GDP) of Natural Gas in 2007 and the Mineral Rent(as % of GDP) of Oil in 2009?
Ensure brevity in your answer.  -0.11. What is the difference between the Mineral Rent(as % of GDP) of Natural Gas in 2007 and the Mineral Rent(as % of GDP) of Other Minerals in 2009?
Make the answer very short. -0.12. What is the difference between the Mineral Rent(as % of GDP) of Oil in 2007 and the Mineral Rent(as % of GDP) of Other Minerals in 2009?
Ensure brevity in your answer.  -0. What is the difference between the Mineral Rent(as % of GDP) of Coal in 2007 and the Mineral Rent(as % of GDP) of Natural Gas in 2010?
Your response must be concise. -0.01. What is the difference between the Mineral Rent(as % of GDP) of Coal in 2007 and the Mineral Rent(as % of GDP) of Oil in 2010?
Provide a succinct answer. -0.15. What is the difference between the Mineral Rent(as % of GDP) in Coal in 2007 and the Mineral Rent(as % of GDP) in Other Minerals in 2010?
Give a very brief answer. -0.25. What is the difference between the Mineral Rent(as % of GDP) in Natural Gas in 2007 and the Mineral Rent(as % of GDP) in Oil in 2010?
Offer a very short reply. -0.13. What is the difference between the Mineral Rent(as % of GDP) in Natural Gas in 2007 and the Mineral Rent(as % of GDP) in Other Minerals in 2010?
Your response must be concise. -0.23. What is the difference between the Mineral Rent(as % of GDP) of Oil in 2007 and the Mineral Rent(as % of GDP) of Other Minerals in 2010?
Offer a very short reply. -0.11. What is the difference between the Mineral Rent(as % of GDP) in Coal in 2007 and the Mineral Rent(as % of GDP) in Natural Gas in 2011?
Make the answer very short. -0.01. What is the difference between the Mineral Rent(as % of GDP) in Coal in 2007 and the Mineral Rent(as % of GDP) in Oil in 2011?
Offer a very short reply. -0.19. What is the difference between the Mineral Rent(as % of GDP) of Coal in 2007 and the Mineral Rent(as % of GDP) of Other Minerals in 2011?
Offer a terse response. -0.34. What is the difference between the Mineral Rent(as % of GDP) of Natural Gas in 2007 and the Mineral Rent(as % of GDP) of Oil in 2011?
Ensure brevity in your answer.  -0.16. What is the difference between the Mineral Rent(as % of GDP) in Natural Gas in 2007 and the Mineral Rent(as % of GDP) in Other Minerals in 2011?
Provide a short and direct response. -0.32. What is the difference between the Mineral Rent(as % of GDP) in Oil in 2007 and the Mineral Rent(as % of GDP) in Other Minerals in 2011?
Offer a terse response. -0.2. What is the difference between the Mineral Rent(as % of GDP) of Coal in 2007 and the Mineral Rent(as % of GDP) of Natural Gas in 2012?
Your answer should be compact. -0. What is the difference between the Mineral Rent(as % of GDP) in Coal in 2007 and the Mineral Rent(as % of GDP) in Oil in 2012?
Offer a very short reply. -0.17. What is the difference between the Mineral Rent(as % of GDP) in Coal in 2007 and the Mineral Rent(as % of GDP) in Other Minerals in 2012?
Make the answer very short. -0.31. What is the difference between the Mineral Rent(as % of GDP) in Natural Gas in 2007 and the Mineral Rent(as % of GDP) in Oil in 2012?
Make the answer very short. -0.15. What is the difference between the Mineral Rent(as % of GDP) in Natural Gas in 2007 and the Mineral Rent(as % of GDP) in Other Minerals in 2012?
Offer a terse response. -0.29. What is the difference between the Mineral Rent(as % of GDP) in Oil in 2007 and the Mineral Rent(as % of GDP) in Other Minerals in 2012?
Offer a terse response. -0.17. What is the difference between the Mineral Rent(as % of GDP) in Coal in 2008 and the Mineral Rent(as % of GDP) in Natural Gas in 2009?
Your response must be concise. 0.06. What is the difference between the Mineral Rent(as % of GDP) of Coal in 2008 and the Mineral Rent(as % of GDP) of Oil in 2009?
Your response must be concise. -0.06. What is the difference between the Mineral Rent(as % of GDP) of Coal in 2008 and the Mineral Rent(as % of GDP) of Other Minerals in 2009?
Keep it short and to the point. -0.08. What is the difference between the Mineral Rent(as % of GDP) in Natural Gas in 2008 and the Mineral Rent(as % of GDP) in Oil in 2009?
Your answer should be compact. -0.09. What is the difference between the Mineral Rent(as % of GDP) of Natural Gas in 2008 and the Mineral Rent(as % of GDP) of Other Minerals in 2009?
Offer a very short reply. -0.11. What is the difference between the Mineral Rent(as % of GDP) in Oil in 2008 and the Mineral Rent(as % of GDP) in Other Minerals in 2009?
Your answer should be very brief. 0.03. What is the difference between the Mineral Rent(as % of GDP) of Coal in 2008 and the Mineral Rent(as % of GDP) of Natural Gas in 2010?
Offer a very short reply. 0.06. What is the difference between the Mineral Rent(as % of GDP) of Coal in 2008 and the Mineral Rent(as % of GDP) of Oil in 2010?
Provide a short and direct response. -0.08. What is the difference between the Mineral Rent(as % of GDP) of Coal in 2008 and the Mineral Rent(as % of GDP) of Other Minerals in 2010?
Make the answer very short. -0.18. What is the difference between the Mineral Rent(as % of GDP) in Natural Gas in 2008 and the Mineral Rent(as % of GDP) in Oil in 2010?
Give a very brief answer. -0.12. What is the difference between the Mineral Rent(as % of GDP) in Natural Gas in 2008 and the Mineral Rent(as % of GDP) in Other Minerals in 2010?
Make the answer very short. -0.21. What is the difference between the Mineral Rent(as % of GDP) in Oil in 2008 and the Mineral Rent(as % of GDP) in Other Minerals in 2010?
Your answer should be compact. -0.07. What is the difference between the Mineral Rent(as % of GDP) in Coal in 2008 and the Mineral Rent(as % of GDP) in Natural Gas in 2011?
Offer a very short reply. 0.06. What is the difference between the Mineral Rent(as % of GDP) of Coal in 2008 and the Mineral Rent(as % of GDP) of Oil in 2011?
Your response must be concise. -0.12. What is the difference between the Mineral Rent(as % of GDP) in Coal in 2008 and the Mineral Rent(as % of GDP) in Other Minerals in 2011?
Your answer should be very brief. -0.27. What is the difference between the Mineral Rent(as % of GDP) in Natural Gas in 2008 and the Mineral Rent(as % of GDP) in Oil in 2011?
Provide a short and direct response. -0.15. What is the difference between the Mineral Rent(as % of GDP) in Natural Gas in 2008 and the Mineral Rent(as % of GDP) in Other Minerals in 2011?
Provide a short and direct response. -0.3. What is the difference between the Mineral Rent(as % of GDP) of Oil in 2008 and the Mineral Rent(as % of GDP) of Other Minerals in 2011?
Provide a short and direct response. -0.16. What is the difference between the Mineral Rent(as % of GDP) in Coal in 2008 and the Mineral Rent(as % of GDP) in Natural Gas in 2012?
Make the answer very short. 0.07. What is the difference between the Mineral Rent(as % of GDP) of Coal in 2008 and the Mineral Rent(as % of GDP) of Oil in 2012?
Provide a short and direct response. -0.1. What is the difference between the Mineral Rent(as % of GDP) of Coal in 2008 and the Mineral Rent(as % of GDP) of Other Minerals in 2012?
Provide a short and direct response. -0.24. What is the difference between the Mineral Rent(as % of GDP) of Natural Gas in 2008 and the Mineral Rent(as % of GDP) of Oil in 2012?
Your answer should be compact. -0.14. What is the difference between the Mineral Rent(as % of GDP) of Natural Gas in 2008 and the Mineral Rent(as % of GDP) of Other Minerals in 2012?
Ensure brevity in your answer.  -0.27. What is the difference between the Mineral Rent(as % of GDP) in Oil in 2008 and the Mineral Rent(as % of GDP) in Other Minerals in 2012?
Your response must be concise. -0.14. What is the difference between the Mineral Rent(as % of GDP) in Coal in 2009 and the Mineral Rent(as % of GDP) in Natural Gas in 2010?
Your answer should be very brief. -0.01. What is the difference between the Mineral Rent(as % of GDP) of Coal in 2009 and the Mineral Rent(as % of GDP) of Oil in 2010?
Make the answer very short. -0.15. What is the difference between the Mineral Rent(as % of GDP) of Coal in 2009 and the Mineral Rent(as % of GDP) of Other Minerals in 2010?
Provide a short and direct response. -0.25. What is the difference between the Mineral Rent(as % of GDP) in Natural Gas in 2009 and the Mineral Rent(as % of GDP) in Oil in 2010?
Your response must be concise. -0.14. What is the difference between the Mineral Rent(as % of GDP) of Natural Gas in 2009 and the Mineral Rent(as % of GDP) of Other Minerals in 2010?
Make the answer very short. -0.24. What is the difference between the Mineral Rent(as % of GDP) in Oil in 2009 and the Mineral Rent(as % of GDP) in Other Minerals in 2010?
Your answer should be compact. -0.12. What is the difference between the Mineral Rent(as % of GDP) in Coal in 2009 and the Mineral Rent(as % of GDP) in Natural Gas in 2011?
Your answer should be very brief. -0.01. What is the difference between the Mineral Rent(as % of GDP) in Coal in 2009 and the Mineral Rent(as % of GDP) in Oil in 2011?
Give a very brief answer. -0.18. What is the difference between the Mineral Rent(as % of GDP) in Coal in 2009 and the Mineral Rent(as % of GDP) in Other Minerals in 2011?
Provide a short and direct response. -0.34. What is the difference between the Mineral Rent(as % of GDP) of Natural Gas in 2009 and the Mineral Rent(as % of GDP) of Oil in 2011?
Your answer should be very brief. -0.18. What is the difference between the Mineral Rent(as % of GDP) of Natural Gas in 2009 and the Mineral Rent(as % of GDP) of Other Minerals in 2011?
Keep it short and to the point. -0.33. What is the difference between the Mineral Rent(as % of GDP) of Oil in 2009 and the Mineral Rent(as % of GDP) of Other Minerals in 2011?
Your answer should be compact. -0.21. What is the difference between the Mineral Rent(as % of GDP) of Coal in 2009 and the Mineral Rent(as % of GDP) of Natural Gas in 2012?
Your response must be concise. -0. What is the difference between the Mineral Rent(as % of GDP) of Coal in 2009 and the Mineral Rent(as % of GDP) of Oil in 2012?
Offer a very short reply. -0.17. What is the difference between the Mineral Rent(as % of GDP) of Coal in 2009 and the Mineral Rent(as % of GDP) of Other Minerals in 2012?
Offer a terse response. -0.31. What is the difference between the Mineral Rent(as % of GDP) in Natural Gas in 2009 and the Mineral Rent(as % of GDP) in Oil in 2012?
Ensure brevity in your answer.  -0.16. What is the difference between the Mineral Rent(as % of GDP) of Natural Gas in 2009 and the Mineral Rent(as % of GDP) of Other Minerals in 2012?
Ensure brevity in your answer.  -0.3. What is the difference between the Mineral Rent(as % of GDP) in Oil in 2009 and the Mineral Rent(as % of GDP) in Other Minerals in 2012?
Your response must be concise. -0.18. What is the difference between the Mineral Rent(as % of GDP) in Coal in 2010 and the Mineral Rent(as % of GDP) in Natural Gas in 2011?
Give a very brief answer. 0.01. What is the difference between the Mineral Rent(as % of GDP) in Coal in 2010 and the Mineral Rent(as % of GDP) in Oil in 2011?
Offer a very short reply. -0.16. What is the difference between the Mineral Rent(as % of GDP) in Coal in 2010 and the Mineral Rent(as % of GDP) in Other Minerals in 2011?
Provide a succinct answer. -0.32. What is the difference between the Mineral Rent(as % of GDP) in Natural Gas in 2010 and the Mineral Rent(as % of GDP) in Oil in 2011?
Your response must be concise. -0.18. What is the difference between the Mineral Rent(as % of GDP) in Natural Gas in 2010 and the Mineral Rent(as % of GDP) in Other Minerals in 2011?
Ensure brevity in your answer.  -0.34. What is the difference between the Mineral Rent(as % of GDP) in Oil in 2010 and the Mineral Rent(as % of GDP) in Other Minerals in 2011?
Provide a short and direct response. -0.19. What is the difference between the Mineral Rent(as % of GDP) of Coal in 2010 and the Mineral Rent(as % of GDP) of Natural Gas in 2012?
Offer a very short reply. 0.02. What is the difference between the Mineral Rent(as % of GDP) of Coal in 2010 and the Mineral Rent(as % of GDP) of Oil in 2012?
Your response must be concise. -0.15. What is the difference between the Mineral Rent(as % of GDP) of Coal in 2010 and the Mineral Rent(as % of GDP) of Other Minerals in 2012?
Ensure brevity in your answer.  -0.29. What is the difference between the Mineral Rent(as % of GDP) in Natural Gas in 2010 and the Mineral Rent(as % of GDP) in Oil in 2012?
Offer a terse response. -0.17. What is the difference between the Mineral Rent(as % of GDP) in Natural Gas in 2010 and the Mineral Rent(as % of GDP) in Other Minerals in 2012?
Give a very brief answer. -0.31. What is the difference between the Mineral Rent(as % of GDP) in Oil in 2010 and the Mineral Rent(as % of GDP) in Other Minerals in 2012?
Your answer should be compact. -0.16. What is the difference between the Mineral Rent(as % of GDP) of Coal in 2011 and the Mineral Rent(as % of GDP) of Natural Gas in 2012?
Provide a succinct answer. 0.07. What is the difference between the Mineral Rent(as % of GDP) in Coal in 2011 and the Mineral Rent(as % of GDP) in Oil in 2012?
Provide a succinct answer. -0.1. What is the difference between the Mineral Rent(as % of GDP) of Coal in 2011 and the Mineral Rent(as % of GDP) of Other Minerals in 2012?
Keep it short and to the point. -0.24. What is the difference between the Mineral Rent(as % of GDP) of Natural Gas in 2011 and the Mineral Rent(as % of GDP) of Oil in 2012?
Your response must be concise. -0.17. What is the difference between the Mineral Rent(as % of GDP) in Natural Gas in 2011 and the Mineral Rent(as % of GDP) in Other Minerals in 2012?
Give a very brief answer. -0.31. What is the difference between the Mineral Rent(as % of GDP) of Oil in 2011 and the Mineral Rent(as % of GDP) of Other Minerals in 2012?
Provide a succinct answer. -0.13. What is the average Mineral Rent(as % of GDP) in Coal per year?
Provide a succinct answer. 0.02. What is the average Mineral Rent(as % of GDP) of Natural Gas per year?
Your answer should be very brief. 0.02. What is the average Mineral Rent(as % of GDP) of Oil per year?
Ensure brevity in your answer.  0.16. What is the average Mineral Rent(as % of GDP) in Other Minerals per year?
Your answer should be compact. 0.19. In the year 2004, what is the difference between the Mineral Rent(as % of GDP) of Coal and Mineral Rent(as % of GDP) of Natural Gas?
Provide a short and direct response. -0.02. In the year 2004, what is the difference between the Mineral Rent(as % of GDP) in Coal and Mineral Rent(as % of GDP) in Oil?
Keep it short and to the point. -0.13. In the year 2004, what is the difference between the Mineral Rent(as % of GDP) in Coal and Mineral Rent(as % of GDP) in Other Minerals?
Offer a terse response. -0.03. In the year 2004, what is the difference between the Mineral Rent(as % of GDP) of Natural Gas and Mineral Rent(as % of GDP) of Oil?
Your answer should be very brief. -0.11. In the year 2004, what is the difference between the Mineral Rent(as % of GDP) of Natural Gas and Mineral Rent(as % of GDP) of Other Minerals?
Your answer should be compact. -0.01. In the year 2004, what is the difference between the Mineral Rent(as % of GDP) of Oil and Mineral Rent(as % of GDP) of Other Minerals?
Give a very brief answer. 0.1. In the year 2005, what is the difference between the Mineral Rent(as % of GDP) of Coal and Mineral Rent(as % of GDP) of Natural Gas?
Offer a terse response. -0.04. In the year 2005, what is the difference between the Mineral Rent(as % of GDP) of Coal and Mineral Rent(as % of GDP) of Oil?
Keep it short and to the point. -0.16. In the year 2005, what is the difference between the Mineral Rent(as % of GDP) of Coal and Mineral Rent(as % of GDP) of Other Minerals?
Provide a short and direct response. -0.07. In the year 2005, what is the difference between the Mineral Rent(as % of GDP) of Natural Gas and Mineral Rent(as % of GDP) of Oil?
Offer a very short reply. -0.12. In the year 2005, what is the difference between the Mineral Rent(as % of GDP) of Natural Gas and Mineral Rent(as % of GDP) of Other Minerals?
Make the answer very short. -0.03. In the year 2005, what is the difference between the Mineral Rent(as % of GDP) in Oil and Mineral Rent(as % of GDP) in Other Minerals?
Your answer should be compact. 0.09. In the year 2006, what is the difference between the Mineral Rent(as % of GDP) in Coal and Mineral Rent(as % of GDP) in Natural Gas?
Your response must be concise. -0.03. In the year 2006, what is the difference between the Mineral Rent(as % of GDP) of Coal and Mineral Rent(as % of GDP) of Oil?
Provide a succinct answer. -0.16. In the year 2006, what is the difference between the Mineral Rent(as % of GDP) in Coal and Mineral Rent(as % of GDP) in Other Minerals?
Your answer should be very brief. -0.14. In the year 2006, what is the difference between the Mineral Rent(as % of GDP) of Natural Gas and Mineral Rent(as % of GDP) of Oil?
Offer a very short reply. -0.13. In the year 2006, what is the difference between the Mineral Rent(as % of GDP) in Natural Gas and Mineral Rent(as % of GDP) in Other Minerals?
Offer a very short reply. -0.1. In the year 2006, what is the difference between the Mineral Rent(as % of GDP) of Oil and Mineral Rent(as % of GDP) of Other Minerals?
Offer a very short reply. 0.03. In the year 2007, what is the difference between the Mineral Rent(as % of GDP) of Coal and Mineral Rent(as % of GDP) of Natural Gas?
Keep it short and to the point. -0.02. In the year 2007, what is the difference between the Mineral Rent(as % of GDP) of Coal and Mineral Rent(as % of GDP) of Oil?
Give a very brief answer. -0.14. In the year 2007, what is the difference between the Mineral Rent(as % of GDP) in Coal and Mineral Rent(as % of GDP) in Other Minerals?
Make the answer very short. -0.18. In the year 2007, what is the difference between the Mineral Rent(as % of GDP) of Natural Gas and Mineral Rent(as % of GDP) of Oil?
Your response must be concise. -0.12. In the year 2007, what is the difference between the Mineral Rent(as % of GDP) in Natural Gas and Mineral Rent(as % of GDP) in Other Minerals?
Provide a short and direct response. -0.16. In the year 2007, what is the difference between the Mineral Rent(as % of GDP) of Oil and Mineral Rent(as % of GDP) of Other Minerals?
Keep it short and to the point. -0.04. In the year 2008, what is the difference between the Mineral Rent(as % of GDP) in Coal and Mineral Rent(as % of GDP) in Natural Gas?
Offer a terse response. 0.03. In the year 2008, what is the difference between the Mineral Rent(as % of GDP) in Coal and Mineral Rent(as % of GDP) in Oil?
Give a very brief answer. -0.11. In the year 2008, what is the difference between the Mineral Rent(as % of GDP) in Coal and Mineral Rent(as % of GDP) in Other Minerals?
Your answer should be very brief. -0.11. In the year 2008, what is the difference between the Mineral Rent(as % of GDP) in Natural Gas and Mineral Rent(as % of GDP) in Oil?
Make the answer very short. -0.14. In the year 2008, what is the difference between the Mineral Rent(as % of GDP) in Natural Gas and Mineral Rent(as % of GDP) in Other Minerals?
Your answer should be very brief. -0.14. In the year 2008, what is the difference between the Mineral Rent(as % of GDP) in Oil and Mineral Rent(as % of GDP) in Other Minerals?
Offer a very short reply. -0. In the year 2009, what is the difference between the Mineral Rent(as % of GDP) in Coal and Mineral Rent(as % of GDP) in Natural Gas?
Make the answer very short. -0.01. In the year 2009, what is the difference between the Mineral Rent(as % of GDP) in Coal and Mineral Rent(as % of GDP) in Oil?
Your response must be concise. -0.13. In the year 2009, what is the difference between the Mineral Rent(as % of GDP) of Coal and Mineral Rent(as % of GDP) of Other Minerals?
Ensure brevity in your answer.  -0.14. In the year 2009, what is the difference between the Mineral Rent(as % of GDP) of Natural Gas and Mineral Rent(as % of GDP) of Oil?
Provide a short and direct response. -0.12. In the year 2009, what is the difference between the Mineral Rent(as % of GDP) in Natural Gas and Mineral Rent(as % of GDP) in Other Minerals?
Provide a succinct answer. -0.14. In the year 2009, what is the difference between the Mineral Rent(as % of GDP) of Oil and Mineral Rent(as % of GDP) of Other Minerals?
Make the answer very short. -0.01. In the year 2010, what is the difference between the Mineral Rent(as % of GDP) in Coal and Mineral Rent(as % of GDP) in Natural Gas?
Give a very brief answer. 0.02. In the year 2010, what is the difference between the Mineral Rent(as % of GDP) in Coal and Mineral Rent(as % of GDP) in Oil?
Your answer should be very brief. -0.13. In the year 2010, what is the difference between the Mineral Rent(as % of GDP) in Coal and Mineral Rent(as % of GDP) in Other Minerals?
Your answer should be compact. -0.23. In the year 2010, what is the difference between the Mineral Rent(as % of GDP) of Natural Gas and Mineral Rent(as % of GDP) of Oil?
Your response must be concise. -0.15. In the year 2010, what is the difference between the Mineral Rent(as % of GDP) in Natural Gas and Mineral Rent(as % of GDP) in Other Minerals?
Offer a terse response. -0.25. In the year 2010, what is the difference between the Mineral Rent(as % of GDP) in Oil and Mineral Rent(as % of GDP) in Other Minerals?
Make the answer very short. -0.1. In the year 2011, what is the difference between the Mineral Rent(as % of GDP) of Coal and Mineral Rent(as % of GDP) of Natural Gas?
Your answer should be very brief. 0.06. In the year 2011, what is the difference between the Mineral Rent(as % of GDP) of Coal and Mineral Rent(as % of GDP) of Oil?
Offer a very short reply. -0.11. In the year 2011, what is the difference between the Mineral Rent(as % of GDP) in Coal and Mineral Rent(as % of GDP) in Other Minerals?
Ensure brevity in your answer.  -0.27. In the year 2011, what is the difference between the Mineral Rent(as % of GDP) in Natural Gas and Mineral Rent(as % of GDP) in Oil?
Your answer should be very brief. -0.18. In the year 2011, what is the difference between the Mineral Rent(as % of GDP) of Natural Gas and Mineral Rent(as % of GDP) of Other Minerals?
Provide a short and direct response. -0.33. In the year 2011, what is the difference between the Mineral Rent(as % of GDP) of Oil and Mineral Rent(as % of GDP) of Other Minerals?
Your answer should be compact. -0.16. In the year 2012, what is the difference between the Mineral Rent(as % of GDP) of Coal and Mineral Rent(as % of GDP) of Natural Gas?
Your answer should be very brief. 0.01. In the year 2012, what is the difference between the Mineral Rent(as % of GDP) in Coal and Mineral Rent(as % of GDP) in Oil?
Your answer should be compact. -0.16. In the year 2012, what is the difference between the Mineral Rent(as % of GDP) in Coal and Mineral Rent(as % of GDP) in Other Minerals?
Offer a terse response. -0.3. In the year 2012, what is the difference between the Mineral Rent(as % of GDP) of Natural Gas and Mineral Rent(as % of GDP) of Oil?
Provide a succinct answer. -0.17. In the year 2012, what is the difference between the Mineral Rent(as % of GDP) of Natural Gas and Mineral Rent(as % of GDP) of Other Minerals?
Make the answer very short. -0.31. In the year 2012, what is the difference between the Mineral Rent(as % of GDP) of Oil and Mineral Rent(as % of GDP) of Other Minerals?
Provide a succinct answer. -0.14. What is the ratio of the Mineral Rent(as % of GDP) of Coal in 2004 to that in 2005?
Your answer should be very brief. 4.63. What is the ratio of the Mineral Rent(as % of GDP) in Natural Gas in 2004 to that in 2005?
Your answer should be compact. 0.59. What is the ratio of the Mineral Rent(as % of GDP) in Oil in 2004 to that in 2005?
Keep it short and to the point. 0.84. What is the ratio of the Mineral Rent(as % of GDP) in Other Minerals in 2004 to that in 2005?
Your response must be concise. 0.5. What is the ratio of the Mineral Rent(as % of GDP) in Coal in 2004 to that in 2006?
Your answer should be very brief. 2.79. What is the ratio of the Mineral Rent(as % of GDP) of Natural Gas in 2004 to that in 2006?
Offer a very short reply. 0.67. What is the ratio of the Mineral Rent(as % of GDP) in Oil in 2004 to that in 2006?
Your answer should be very brief. 0.79. What is the ratio of the Mineral Rent(as % of GDP) of Other Minerals in 2004 to that in 2006?
Your answer should be very brief. 0.24. What is the ratio of the Mineral Rent(as % of GDP) of Coal in 2004 to that in 2007?
Your response must be concise. 1.3. What is the ratio of the Mineral Rent(as % of GDP) of Natural Gas in 2004 to that in 2007?
Keep it short and to the point. 0.83. What is the ratio of the Mineral Rent(as % of GDP) of Oil in 2004 to that in 2007?
Provide a succinct answer. 0.89. What is the ratio of the Mineral Rent(as % of GDP) of Other Minerals in 2004 to that in 2007?
Offer a terse response. 0.18. What is the ratio of the Mineral Rent(as % of GDP) of Coal in 2004 to that in 2008?
Give a very brief answer. 0.07. What is the ratio of the Mineral Rent(as % of GDP) of Natural Gas in 2004 to that in 2008?
Offer a very short reply. 0.56. What is the ratio of the Mineral Rent(as % of GDP) of Oil in 2004 to that in 2008?
Your response must be concise. 0.72. What is the ratio of the Mineral Rent(as % of GDP) of Other Minerals in 2004 to that in 2008?
Provide a succinct answer. 0.18. What is the ratio of the Mineral Rent(as % of GDP) of Coal in 2004 to that in 2009?
Provide a short and direct response. 0.98. What is the ratio of the Mineral Rent(as % of GDP) in Natural Gas in 2004 to that in 2009?
Ensure brevity in your answer.  1.66. What is the ratio of the Mineral Rent(as % of GDP) of Oil in 2004 to that in 2009?
Your answer should be compact. 0.97. What is the ratio of the Mineral Rent(as % of GDP) of Other Minerals in 2004 to that in 2009?
Ensure brevity in your answer.  0.22. What is the ratio of the Mineral Rent(as % of GDP) of Coal in 2004 to that in 2010?
Provide a succinct answer. 0.2. What is the ratio of the Mineral Rent(as % of GDP) in Natural Gas in 2004 to that in 2010?
Provide a succinct answer. 2.19. What is the ratio of the Mineral Rent(as % of GDP) in Oil in 2004 to that in 2010?
Ensure brevity in your answer.  0.83. What is the ratio of the Mineral Rent(as % of GDP) of Other Minerals in 2004 to that in 2010?
Provide a succinct answer. 0.13. What is the ratio of the Mineral Rent(as % of GDP) in Coal in 2004 to that in 2011?
Make the answer very short. 0.07. What is the ratio of the Mineral Rent(as % of GDP) in Natural Gas in 2004 to that in 2011?
Your response must be concise. 1.92. What is the ratio of the Mineral Rent(as % of GDP) in Oil in 2004 to that in 2011?
Make the answer very short. 0.69. What is the ratio of the Mineral Rent(as % of GDP) of Other Minerals in 2004 to that in 2011?
Keep it short and to the point. 0.1. What is the ratio of the Mineral Rent(as % of GDP) in Coal in 2004 to that in 2012?
Ensure brevity in your answer.  0.36. What is the ratio of the Mineral Rent(as % of GDP) in Natural Gas in 2004 to that in 2012?
Offer a very short reply. 2.98. What is the ratio of the Mineral Rent(as % of GDP) in Oil in 2004 to that in 2012?
Ensure brevity in your answer.  0.73. What is the ratio of the Mineral Rent(as % of GDP) in Other Minerals in 2004 to that in 2012?
Keep it short and to the point. 0.1. What is the ratio of the Mineral Rent(as % of GDP) in Coal in 2005 to that in 2006?
Ensure brevity in your answer.  0.6. What is the ratio of the Mineral Rent(as % of GDP) in Natural Gas in 2005 to that in 2006?
Make the answer very short. 1.14. What is the ratio of the Mineral Rent(as % of GDP) in Oil in 2005 to that in 2006?
Your response must be concise. 0.95. What is the ratio of the Mineral Rent(as % of GDP) of Other Minerals in 2005 to that in 2006?
Give a very brief answer. 0.47. What is the ratio of the Mineral Rent(as % of GDP) of Coal in 2005 to that in 2007?
Provide a succinct answer. 0.28. What is the ratio of the Mineral Rent(as % of GDP) of Natural Gas in 2005 to that in 2007?
Keep it short and to the point. 1.42. What is the ratio of the Mineral Rent(as % of GDP) in Oil in 2005 to that in 2007?
Provide a short and direct response. 1.06. What is the ratio of the Mineral Rent(as % of GDP) in Other Minerals in 2005 to that in 2007?
Your answer should be compact. 0.36. What is the ratio of the Mineral Rent(as % of GDP) in Coal in 2005 to that in 2008?
Provide a short and direct response. 0.02. What is the ratio of the Mineral Rent(as % of GDP) of Natural Gas in 2005 to that in 2008?
Offer a terse response. 0.95. What is the ratio of the Mineral Rent(as % of GDP) of Oil in 2005 to that in 2008?
Your response must be concise. 0.86. What is the ratio of the Mineral Rent(as % of GDP) in Other Minerals in 2005 to that in 2008?
Your response must be concise. 0.36. What is the ratio of the Mineral Rent(as % of GDP) of Coal in 2005 to that in 2009?
Make the answer very short. 0.21. What is the ratio of the Mineral Rent(as % of GDP) of Natural Gas in 2005 to that in 2009?
Offer a terse response. 2.83. What is the ratio of the Mineral Rent(as % of GDP) in Oil in 2005 to that in 2009?
Your answer should be very brief. 1.16. What is the ratio of the Mineral Rent(as % of GDP) in Other Minerals in 2005 to that in 2009?
Make the answer very short. 0.45. What is the ratio of the Mineral Rent(as % of GDP) in Coal in 2005 to that in 2010?
Keep it short and to the point. 0.04. What is the ratio of the Mineral Rent(as % of GDP) in Natural Gas in 2005 to that in 2010?
Your answer should be very brief. 3.72. What is the ratio of the Mineral Rent(as % of GDP) in Oil in 2005 to that in 2010?
Provide a succinct answer. 0.99. What is the ratio of the Mineral Rent(as % of GDP) in Other Minerals in 2005 to that in 2010?
Offer a terse response. 0.26. What is the ratio of the Mineral Rent(as % of GDP) of Coal in 2005 to that in 2011?
Ensure brevity in your answer.  0.01. What is the ratio of the Mineral Rent(as % of GDP) in Natural Gas in 2005 to that in 2011?
Provide a succinct answer. 3.26. What is the ratio of the Mineral Rent(as % of GDP) in Oil in 2005 to that in 2011?
Give a very brief answer. 0.83. What is the ratio of the Mineral Rent(as % of GDP) of Other Minerals in 2005 to that in 2011?
Offer a terse response. 0.19. What is the ratio of the Mineral Rent(as % of GDP) in Coal in 2005 to that in 2012?
Keep it short and to the point. 0.08. What is the ratio of the Mineral Rent(as % of GDP) of Natural Gas in 2005 to that in 2012?
Provide a short and direct response. 5.06. What is the ratio of the Mineral Rent(as % of GDP) of Oil in 2005 to that in 2012?
Keep it short and to the point. 0.88. What is the ratio of the Mineral Rent(as % of GDP) of Other Minerals in 2005 to that in 2012?
Make the answer very short. 0.21. What is the ratio of the Mineral Rent(as % of GDP) in Coal in 2006 to that in 2007?
Your answer should be compact. 0.46. What is the ratio of the Mineral Rent(as % of GDP) in Natural Gas in 2006 to that in 2007?
Your answer should be compact. 1.25. What is the ratio of the Mineral Rent(as % of GDP) in Oil in 2006 to that in 2007?
Your response must be concise. 1.12. What is the ratio of the Mineral Rent(as % of GDP) in Other Minerals in 2006 to that in 2007?
Provide a short and direct response. 0.75. What is the ratio of the Mineral Rent(as % of GDP) in Coal in 2006 to that in 2008?
Offer a terse response. 0.03. What is the ratio of the Mineral Rent(as % of GDP) in Natural Gas in 2006 to that in 2008?
Keep it short and to the point. 0.83. What is the ratio of the Mineral Rent(as % of GDP) of Oil in 2006 to that in 2008?
Make the answer very short. 0.91. What is the ratio of the Mineral Rent(as % of GDP) of Other Minerals in 2006 to that in 2008?
Your answer should be compact. 0.75. What is the ratio of the Mineral Rent(as % of GDP) in Coal in 2006 to that in 2009?
Your response must be concise. 0.35. What is the ratio of the Mineral Rent(as % of GDP) in Natural Gas in 2006 to that in 2009?
Provide a succinct answer. 2.49. What is the ratio of the Mineral Rent(as % of GDP) in Oil in 2006 to that in 2009?
Make the answer very short. 1.22. What is the ratio of the Mineral Rent(as % of GDP) of Other Minerals in 2006 to that in 2009?
Provide a short and direct response. 0.94. What is the ratio of the Mineral Rent(as % of GDP) in Coal in 2006 to that in 2010?
Your answer should be compact. 0.07. What is the ratio of the Mineral Rent(as % of GDP) in Natural Gas in 2006 to that in 2010?
Keep it short and to the point. 3.28. What is the ratio of the Mineral Rent(as % of GDP) of Oil in 2006 to that in 2010?
Provide a short and direct response. 1.05. What is the ratio of the Mineral Rent(as % of GDP) of Other Minerals in 2006 to that in 2010?
Your answer should be very brief. 0.55. What is the ratio of the Mineral Rent(as % of GDP) of Coal in 2006 to that in 2011?
Offer a terse response. 0.02. What is the ratio of the Mineral Rent(as % of GDP) of Natural Gas in 2006 to that in 2011?
Offer a very short reply. 2.87. What is the ratio of the Mineral Rent(as % of GDP) in Oil in 2006 to that in 2011?
Ensure brevity in your answer.  0.87. What is the ratio of the Mineral Rent(as % of GDP) of Other Minerals in 2006 to that in 2011?
Provide a short and direct response. 0.4. What is the ratio of the Mineral Rent(as % of GDP) of Coal in 2006 to that in 2012?
Provide a succinct answer. 0.13. What is the ratio of the Mineral Rent(as % of GDP) in Natural Gas in 2006 to that in 2012?
Ensure brevity in your answer.  4.46. What is the ratio of the Mineral Rent(as % of GDP) in Oil in 2006 to that in 2012?
Offer a terse response. 0.93. What is the ratio of the Mineral Rent(as % of GDP) in Other Minerals in 2006 to that in 2012?
Your answer should be very brief. 0.44. What is the ratio of the Mineral Rent(as % of GDP) of Coal in 2007 to that in 2008?
Provide a short and direct response. 0.06. What is the ratio of the Mineral Rent(as % of GDP) in Natural Gas in 2007 to that in 2008?
Provide a short and direct response. 0.67. What is the ratio of the Mineral Rent(as % of GDP) of Oil in 2007 to that in 2008?
Your answer should be compact. 0.81. What is the ratio of the Mineral Rent(as % of GDP) of Coal in 2007 to that in 2009?
Offer a terse response. 0.76. What is the ratio of the Mineral Rent(as % of GDP) in Natural Gas in 2007 to that in 2009?
Keep it short and to the point. 2. What is the ratio of the Mineral Rent(as % of GDP) of Oil in 2007 to that in 2009?
Provide a succinct answer. 1.09. What is the ratio of the Mineral Rent(as % of GDP) of Other Minerals in 2007 to that in 2009?
Provide a succinct answer. 1.25. What is the ratio of the Mineral Rent(as % of GDP) in Coal in 2007 to that in 2010?
Your answer should be very brief. 0.15. What is the ratio of the Mineral Rent(as % of GDP) in Natural Gas in 2007 to that in 2010?
Offer a very short reply. 2.62. What is the ratio of the Mineral Rent(as % of GDP) in Oil in 2007 to that in 2010?
Provide a succinct answer. 0.93. What is the ratio of the Mineral Rent(as % of GDP) of Other Minerals in 2007 to that in 2010?
Give a very brief answer. 0.73. What is the ratio of the Mineral Rent(as % of GDP) in Coal in 2007 to that in 2011?
Your answer should be very brief. 0.05. What is the ratio of the Mineral Rent(as % of GDP) in Natural Gas in 2007 to that in 2011?
Your response must be concise. 2.3. What is the ratio of the Mineral Rent(as % of GDP) in Oil in 2007 to that in 2011?
Make the answer very short. 0.78. What is the ratio of the Mineral Rent(as % of GDP) of Other Minerals in 2007 to that in 2011?
Give a very brief answer. 0.54. What is the ratio of the Mineral Rent(as % of GDP) of Coal in 2007 to that in 2012?
Provide a short and direct response. 0.28. What is the ratio of the Mineral Rent(as % of GDP) of Natural Gas in 2007 to that in 2012?
Give a very brief answer. 3.57. What is the ratio of the Mineral Rent(as % of GDP) of Oil in 2007 to that in 2012?
Your answer should be very brief. 0.83. What is the ratio of the Mineral Rent(as % of GDP) in Other Minerals in 2007 to that in 2012?
Make the answer very short. 0.59. What is the ratio of the Mineral Rent(as % of GDP) in Coal in 2008 to that in 2009?
Keep it short and to the point. 13.69. What is the ratio of the Mineral Rent(as % of GDP) in Natural Gas in 2008 to that in 2009?
Offer a terse response. 2.99. What is the ratio of the Mineral Rent(as % of GDP) of Oil in 2008 to that in 2009?
Provide a short and direct response. 1.34. What is the ratio of the Mineral Rent(as % of GDP) in Other Minerals in 2008 to that in 2009?
Keep it short and to the point. 1.25. What is the ratio of the Mineral Rent(as % of GDP) in Coal in 2008 to that in 2010?
Your answer should be compact. 2.78. What is the ratio of the Mineral Rent(as % of GDP) in Natural Gas in 2008 to that in 2010?
Keep it short and to the point. 3.93. What is the ratio of the Mineral Rent(as % of GDP) in Oil in 2008 to that in 2010?
Provide a succinct answer. 1.15. What is the ratio of the Mineral Rent(as % of GDP) in Other Minerals in 2008 to that in 2010?
Provide a short and direct response. 0.73. What is the ratio of the Mineral Rent(as % of GDP) of Coal in 2008 to that in 2011?
Give a very brief answer. 0.96. What is the ratio of the Mineral Rent(as % of GDP) in Natural Gas in 2008 to that in 2011?
Offer a terse response. 3.44. What is the ratio of the Mineral Rent(as % of GDP) in Oil in 2008 to that in 2011?
Your answer should be very brief. 0.96. What is the ratio of the Mineral Rent(as % of GDP) in Other Minerals in 2008 to that in 2011?
Your answer should be compact. 0.54. What is the ratio of the Mineral Rent(as % of GDP) in Coal in 2008 to that in 2012?
Provide a short and direct response. 4.98. What is the ratio of the Mineral Rent(as % of GDP) in Natural Gas in 2008 to that in 2012?
Provide a short and direct response. 5.34. What is the ratio of the Mineral Rent(as % of GDP) in Oil in 2008 to that in 2012?
Offer a very short reply. 1.02. What is the ratio of the Mineral Rent(as % of GDP) of Other Minerals in 2008 to that in 2012?
Give a very brief answer. 0.59. What is the ratio of the Mineral Rent(as % of GDP) in Coal in 2009 to that in 2010?
Keep it short and to the point. 0.2. What is the ratio of the Mineral Rent(as % of GDP) in Natural Gas in 2009 to that in 2010?
Your response must be concise. 1.31. What is the ratio of the Mineral Rent(as % of GDP) in Oil in 2009 to that in 2010?
Provide a short and direct response. 0.86. What is the ratio of the Mineral Rent(as % of GDP) of Other Minerals in 2009 to that in 2010?
Your answer should be compact. 0.58. What is the ratio of the Mineral Rent(as % of GDP) in Coal in 2009 to that in 2011?
Provide a short and direct response. 0.07. What is the ratio of the Mineral Rent(as % of GDP) of Natural Gas in 2009 to that in 2011?
Make the answer very short. 1.15. What is the ratio of the Mineral Rent(as % of GDP) in Oil in 2009 to that in 2011?
Give a very brief answer. 0.72. What is the ratio of the Mineral Rent(as % of GDP) in Other Minerals in 2009 to that in 2011?
Offer a very short reply. 0.43. What is the ratio of the Mineral Rent(as % of GDP) of Coal in 2009 to that in 2012?
Make the answer very short. 0.36. What is the ratio of the Mineral Rent(as % of GDP) in Natural Gas in 2009 to that in 2012?
Keep it short and to the point. 1.79. What is the ratio of the Mineral Rent(as % of GDP) in Oil in 2009 to that in 2012?
Provide a succinct answer. 0.76. What is the ratio of the Mineral Rent(as % of GDP) in Other Minerals in 2009 to that in 2012?
Make the answer very short. 0.47. What is the ratio of the Mineral Rent(as % of GDP) of Coal in 2010 to that in 2011?
Keep it short and to the point. 0.34. What is the ratio of the Mineral Rent(as % of GDP) in Natural Gas in 2010 to that in 2011?
Provide a short and direct response. 0.88. What is the ratio of the Mineral Rent(as % of GDP) of Oil in 2010 to that in 2011?
Your answer should be very brief. 0.83. What is the ratio of the Mineral Rent(as % of GDP) of Other Minerals in 2010 to that in 2011?
Make the answer very short. 0.74. What is the ratio of the Mineral Rent(as % of GDP) in Coal in 2010 to that in 2012?
Your answer should be very brief. 1.79. What is the ratio of the Mineral Rent(as % of GDP) of Natural Gas in 2010 to that in 2012?
Your answer should be compact. 1.36. What is the ratio of the Mineral Rent(as % of GDP) of Oil in 2010 to that in 2012?
Make the answer very short. 0.89. What is the ratio of the Mineral Rent(as % of GDP) of Other Minerals in 2010 to that in 2012?
Offer a terse response. 0.81. What is the ratio of the Mineral Rent(as % of GDP) of Coal in 2011 to that in 2012?
Keep it short and to the point. 5.2. What is the ratio of the Mineral Rent(as % of GDP) in Natural Gas in 2011 to that in 2012?
Your answer should be very brief. 1.55. What is the ratio of the Mineral Rent(as % of GDP) in Oil in 2011 to that in 2012?
Ensure brevity in your answer.  1.06. What is the ratio of the Mineral Rent(as % of GDP) of Other Minerals in 2011 to that in 2012?
Give a very brief answer. 1.09. What is the difference between the highest and the second highest Mineral Rent(as % of GDP) of Coal?
Ensure brevity in your answer.  0. What is the difference between the highest and the second highest Mineral Rent(as % of GDP) of Natural Gas?
Ensure brevity in your answer.  0. What is the difference between the highest and the second highest Mineral Rent(as % of GDP) in Oil?
Your response must be concise. 0.01. What is the difference between the highest and the second highest Mineral Rent(as % of GDP) in Other Minerals?
Your response must be concise. 0.03. What is the difference between the highest and the lowest Mineral Rent(as % of GDP) in Coal?
Give a very brief answer. 0.08. What is the difference between the highest and the lowest Mineral Rent(as % of GDP) in Natural Gas?
Offer a terse response. 0.04. What is the difference between the highest and the lowest Mineral Rent(as % of GDP) in Oil?
Offer a very short reply. 0.06. What is the difference between the highest and the lowest Mineral Rent(as % of GDP) in Other Minerals?
Ensure brevity in your answer.  0.31. 